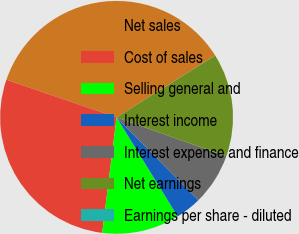Convert chart. <chart><loc_0><loc_0><loc_500><loc_500><pie_chart><fcel>Net sales<fcel>Cost of sales<fcel>Selling general and<fcel>Interest income<fcel>Interest expense and finance<fcel>Net earnings<fcel>Earnings per share - diluted<nl><fcel>35.84%<fcel>28.26%<fcel>10.76%<fcel>3.6%<fcel>7.18%<fcel>14.34%<fcel>0.01%<nl></chart> 